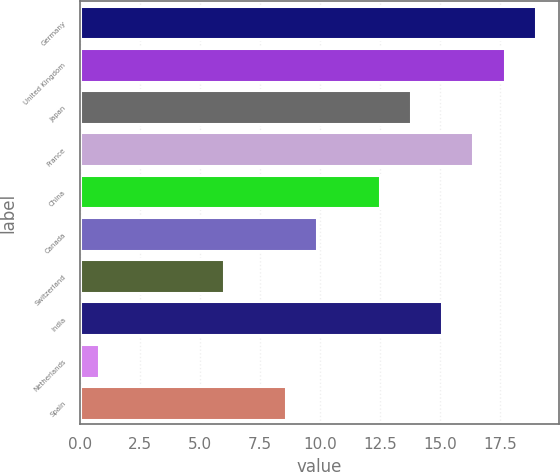<chart> <loc_0><loc_0><loc_500><loc_500><bar_chart><fcel>Germany<fcel>United Kingdom<fcel>Japan<fcel>France<fcel>China<fcel>Canada<fcel>Switzerland<fcel>India<fcel>Netherlands<fcel>Spain<nl><fcel>19<fcel>17.7<fcel>13.8<fcel>16.4<fcel>12.5<fcel>9.9<fcel>6<fcel>15.1<fcel>0.8<fcel>8.6<nl></chart> 